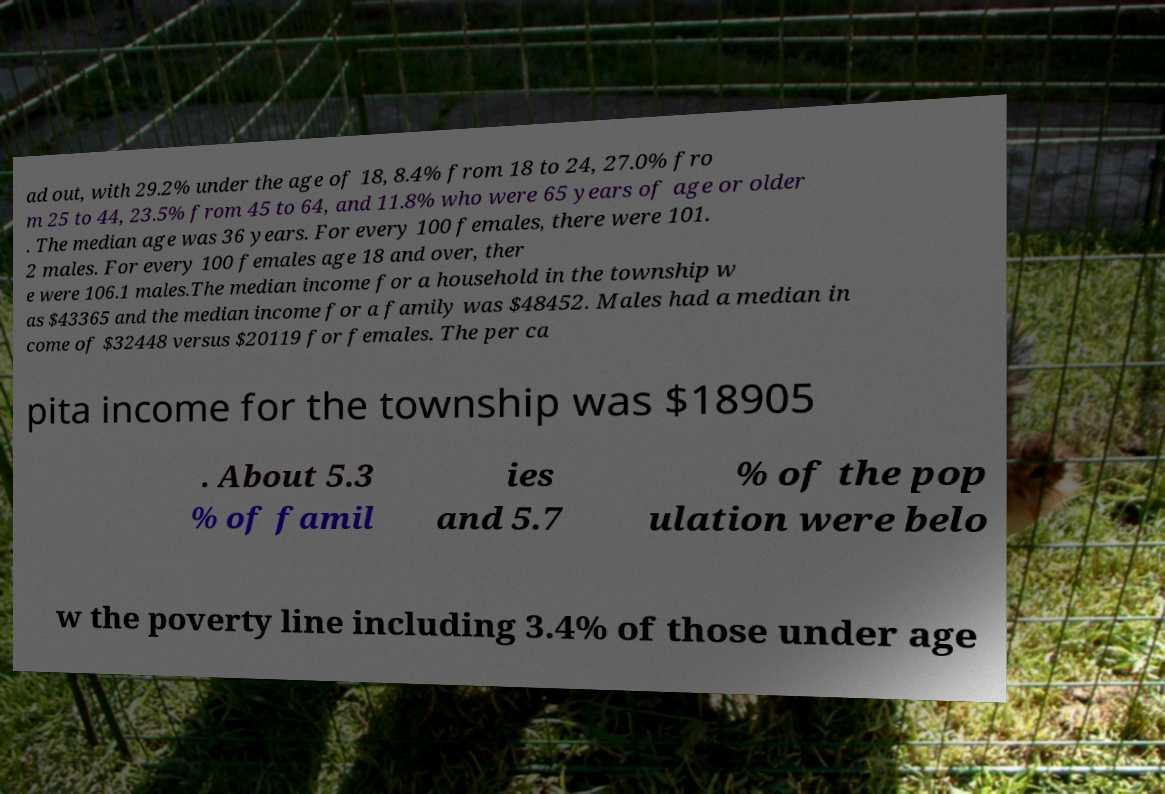Please identify and transcribe the text found in this image. ad out, with 29.2% under the age of 18, 8.4% from 18 to 24, 27.0% fro m 25 to 44, 23.5% from 45 to 64, and 11.8% who were 65 years of age or older . The median age was 36 years. For every 100 females, there were 101. 2 males. For every 100 females age 18 and over, ther e were 106.1 males.The median income for a household in the township w as $43365 and the median income for a family was $48452. Males had a median in come of $32448 versus $20119 for females. The per ca pita income for the township was $18905 . About 5.3 % of famil ies and 5.7 % of the pop ulation were belo w the poverty line including 3.4% of those under age 